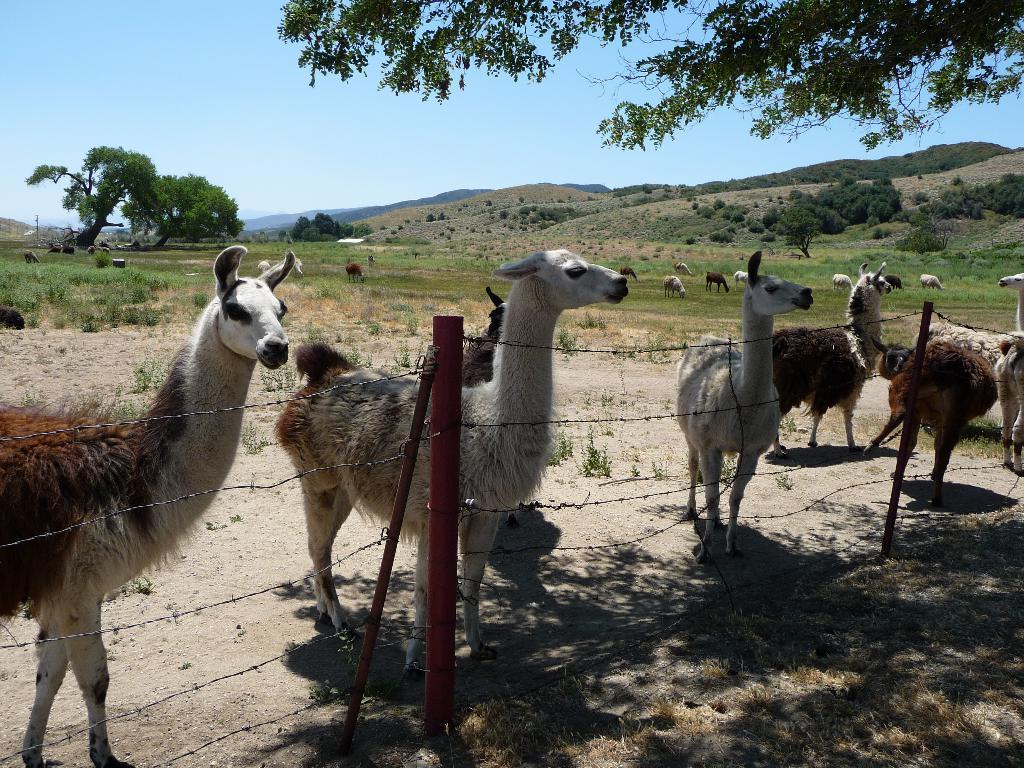Can you describe this image briefly? In this image I can see ground and on it I can see few llamas are standing. I can also few poles, few wires, shadows on ground and In the background I can see number of trees, sky and few more animals are standing. I can see colour of these animals are brown and white. 